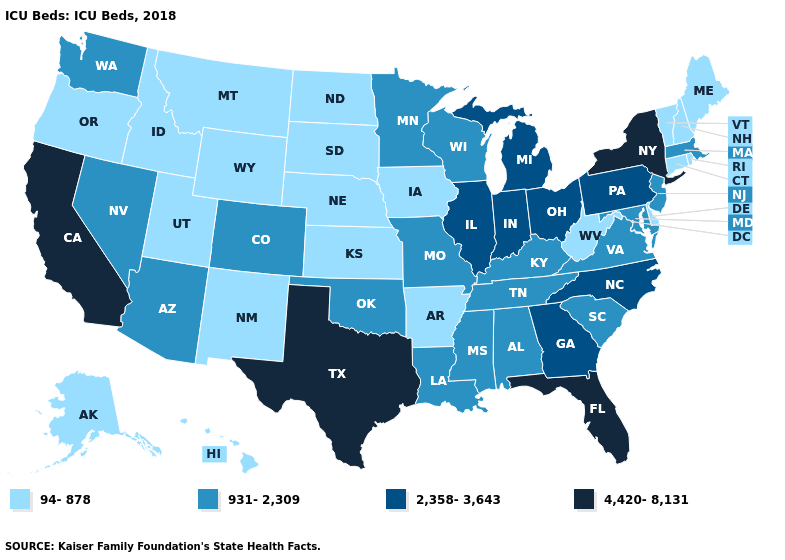What is the value of Tennessee?
Answer briefly. 931-2,309. Does Missouri have the same value as Virginia?
Keep it brief. Yes. Does New York have the highest value in the USA?
Give a very brief answer. Yes. What is the value of Nebraska?
Give a very brief answer. 94-878. Name the states that have a value in the range 931-2,309?
Short answer required. Alabama, Arizona, Colorado, Kentucky, Louisiana, Maryland, Massachusetts, Minnesota, Mississippi, Missouri, Nevada, New Jersey, Oklahoma, South Carolina, Tennessee, Virginia, Washington, Wisconsin. Does Louisiana have the lowest value in the South?
Be succinct. No. Name the states that have a value in the range 2,358-3,643?
Be succinct. Georgia, Illinois, Indiana, Michigan, North Carolina, Ohio, Pennsylvania. Which states have the lowest value in the MidWest?
Short answer required. Iowa, Kansas, Nebraska, North Dakota, South Dakota. Does Vermont have the highest value in the Northeast?
Be succinct. No. What is the highest value in the Northeast ?
Concise answer only. 4,420-8,131. Among the states that border Connecticut , does Rhode Island have the highest value?
Quick response, please. No. What is the value of Texas?
Give a very brief answer. 4,420-8,131. What is the value of Missouri?
Quick response, please. 931-2,309. Does Michigan have the highest value in the MidWest?
Keep it brief. Yes. Name the states that have a value in the range 94-878?
Give a very brief answer. Alaska, Arkansas, Connecticut, Delaware, Hawaii, Idaho, Iowa, Kansas, Maine, Montana, Nebraska, New Hampshire, New Mexico, North Dakota, Oregon, Rhode Island, South Dakota, Utah, Vermont, West Virginia, Wyoming. 